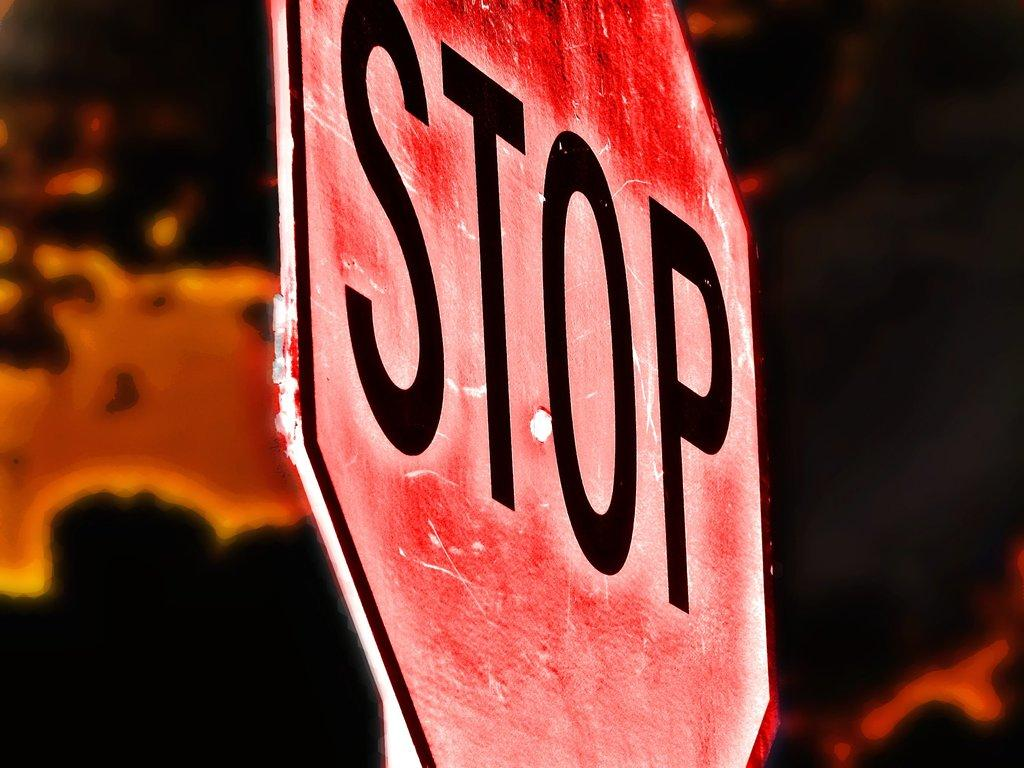<image>
Give a short and clear explanation of the subsequent image. Red and black stop sign up close on road. 